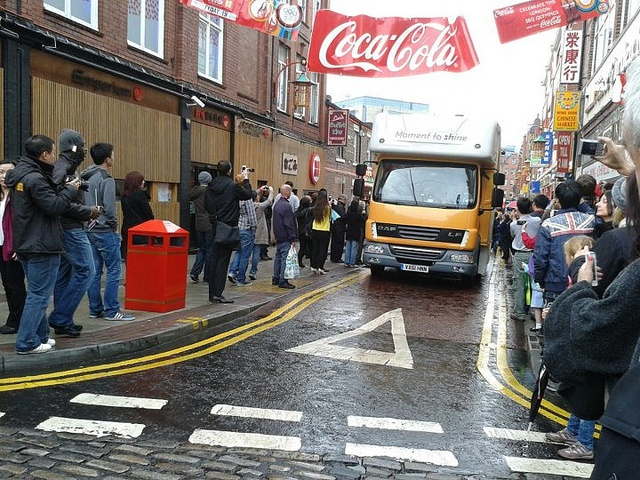Describe the objects in this image and their specific colors. I can see people in black, gray, darkgray, and darkblue tones, truck in black, white, gray, and darkgray tones, people in black, blue, darkblue, and gray tones, people in black, navy, gray, and blue tones, and people in black, gray, navy, and blue tones in this image. 